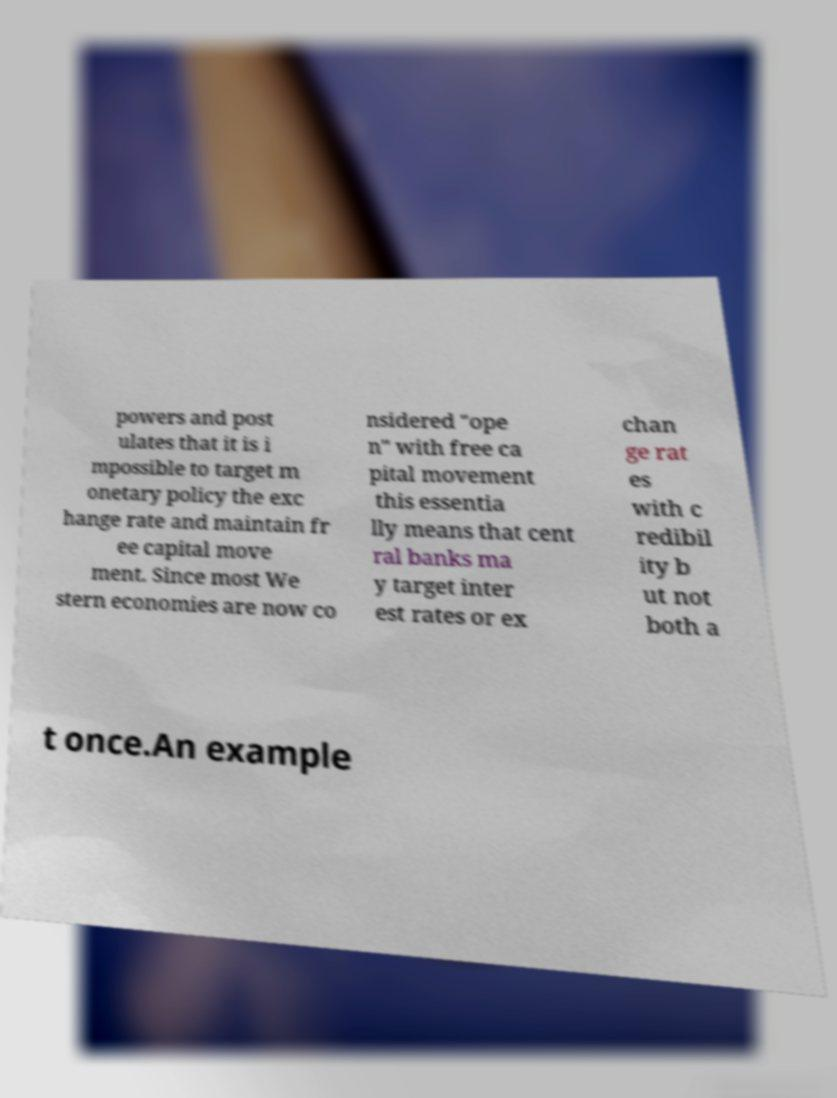There's text embedded in this image that I need extracted. Can you transcribe it verbatim? powers and post ulates that it is i mpossible to target m onetary policy the exc hange rate and maintain fr ee capital move ment. Since most We stern economies are now co nsidered "ope n" with free ca pital movement this essentia lly means that cent ral banks ma y target inter est rates or ex chan ge rat es with c redibil ity b ut not both a t once.An example 